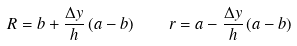<formula> <loc_0><loc_0><loc_500><loc_500>R = b + \frac { \Delta y } { h } \left ( a - b \right ) \quad r = a - \frac { \Delta y } { h } \left ( a - b \right )</formula> 